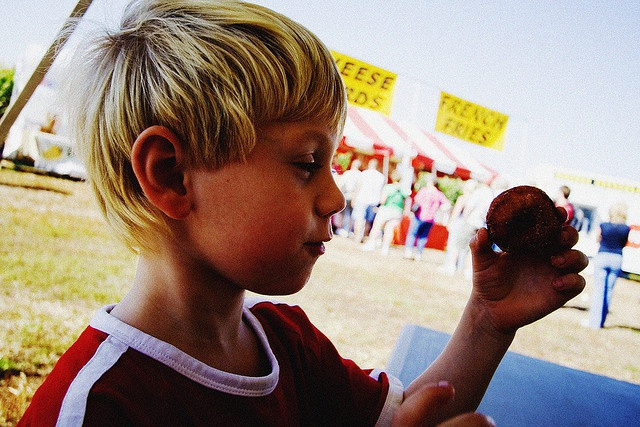Describe the objects in this image and their specific colors. I can see people in lavender, black, maroon, and brown tones, donut in lavender, black, maroon, and brown tones, people in lavender, lightgray, navy, blue, and lightblue tones, people in lavender, white, tan, and darkgray tones, and people in lavender, pink, lightblue, and darkgray tones in this image. 